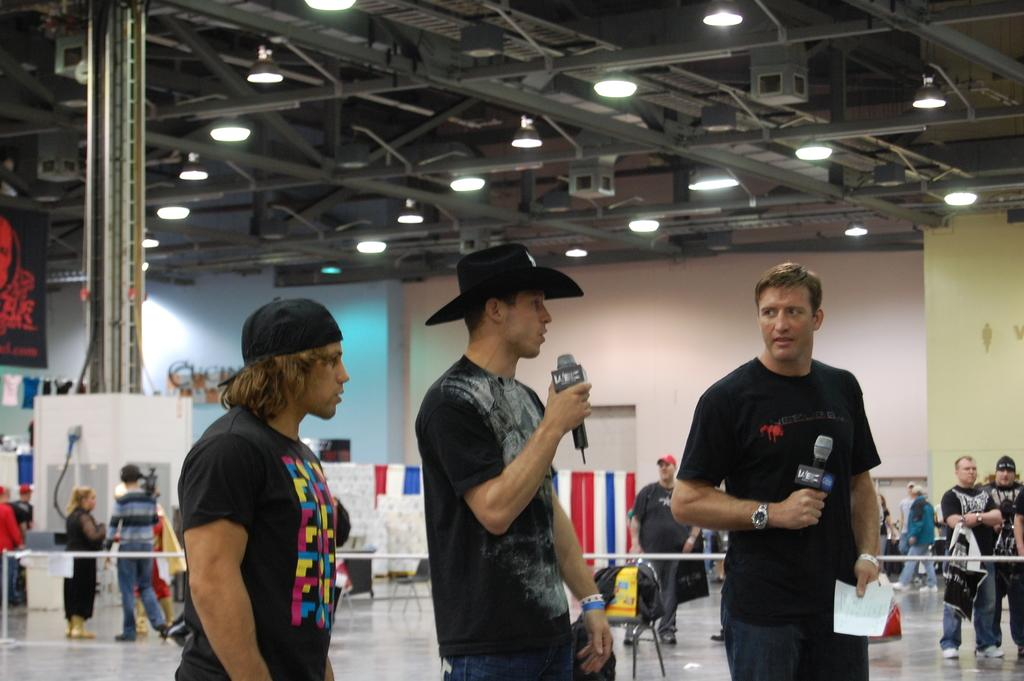How many people are in the image? There are three persons in the image. What are the persons holding in their hands? The persons are holding microphones in their hands. From what perspective is the image taken? The image is taken from a floor level. What can be seen in the background of the image? There are people, boards, lights, and a wall visible in the background. What type of engine is visible in the image? There is no engine present in the image. How many fifths are visible in the image? The term "fifth" does not apply to any elements in the image, as it typically refers to a musical interval or a fraction. 